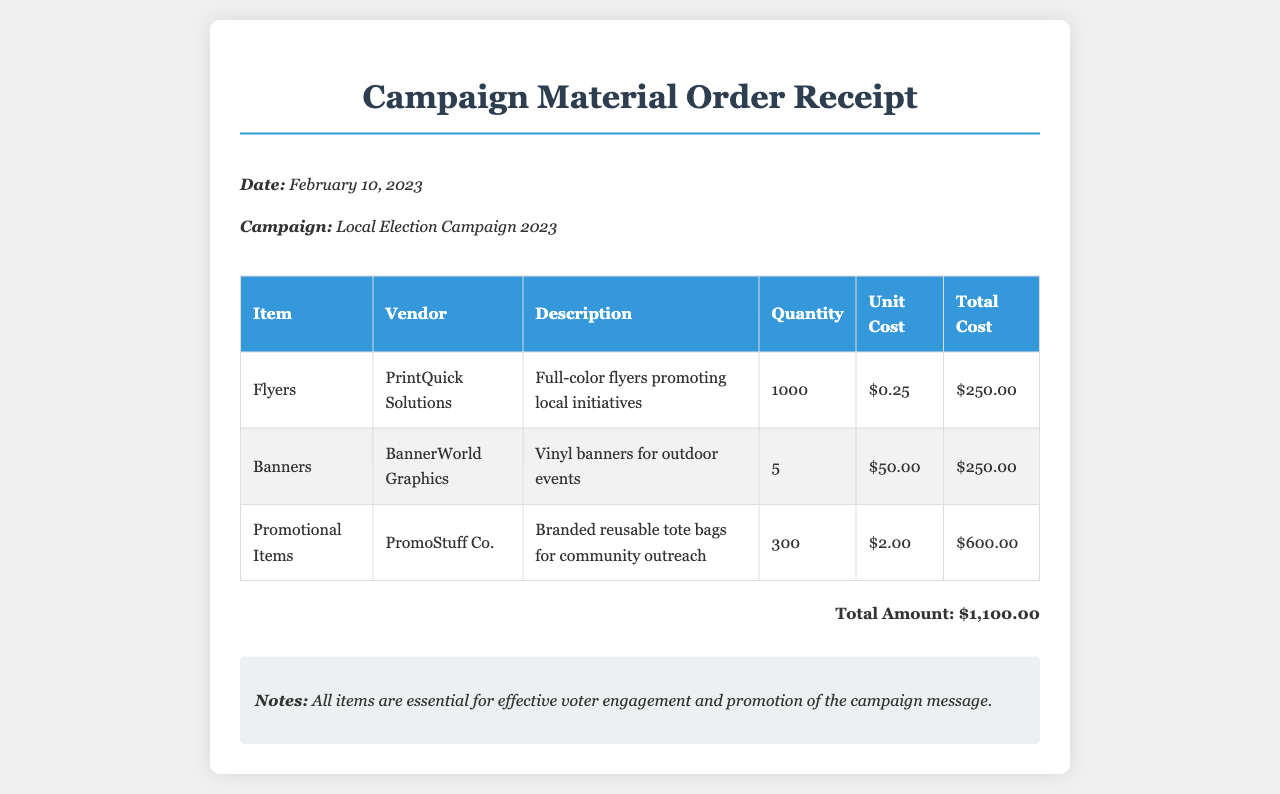What is the date of the receipt? The date is explicitly mentioned in the document as the receipt date.
Answer: February 10, 2023 Who is the vendor for the flyers? The vendor name for the flyers is provided in the receipt's table.
Answer: PrintQuick Solutions How many banners were ordered? The quantity of banners ordered is specified in the table of the document.
Answer: 5 What is the total cost of all items? The total cost is clearly mentioned in the summary section of the document.
Answer: $1,100.00 What type of promotional items were ordered? The description in the table states the type of promotional items ordered.
Answer: Branded reusable tote bags What is the unit cost for the flyers? The unit cost for the flyers can be found in the cost breakdown in the receipt.
Answer: $0.25 Which vendor provided the banners? The vendor information for the banners is indicated in the document's table.
Answer: BannerWorld Graphics What is the total quantity of promotional items ordered? The total quantity is provided in the itemized list in the receipt.
Answer: 300 Why are the items purchased important? The notes section mentions the significance of the items for the campaign.
Answer: Effective voter engagement and promotion of the campaign message 